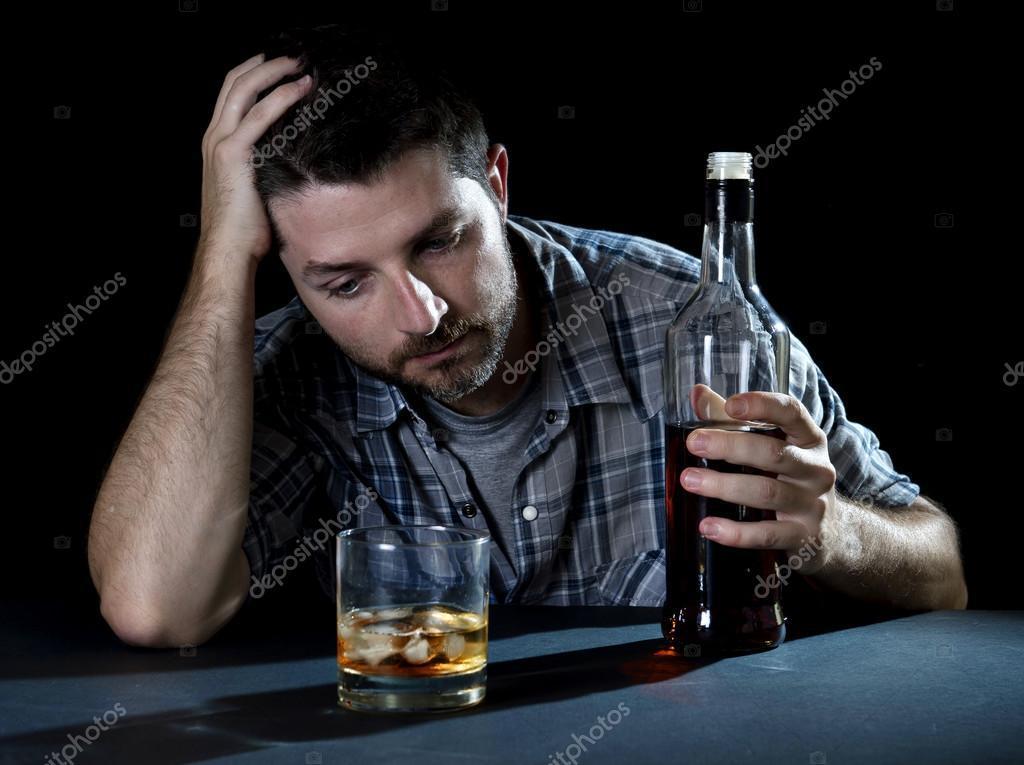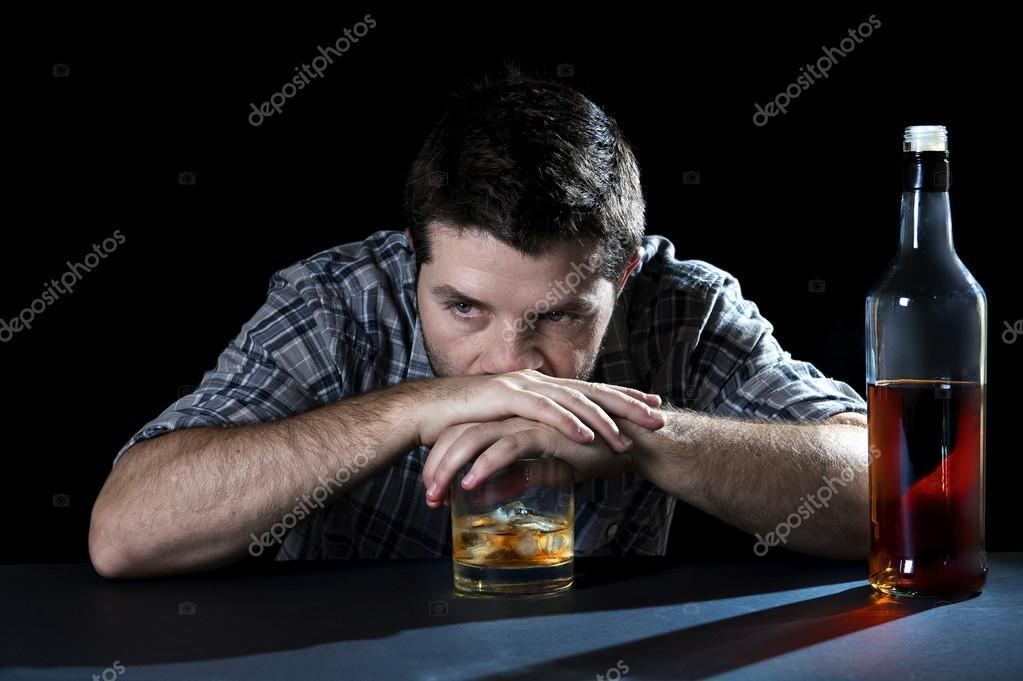The first image is the image on the left, the second image is the image on the right. Analyze the images presented: Is the assertion "The left and right image contains the same number of identical men in the same shirts.." valid? Answer yes or no. Yes. The first image is the image on the left, the second image is the image on the right. Given the left and right images, does the statement "The right image shows a man, sitting on a wide white chair behind bottles on a table, wearing a necktie and holding up a cardboard sign." hold true? Answer yes or no. No. 